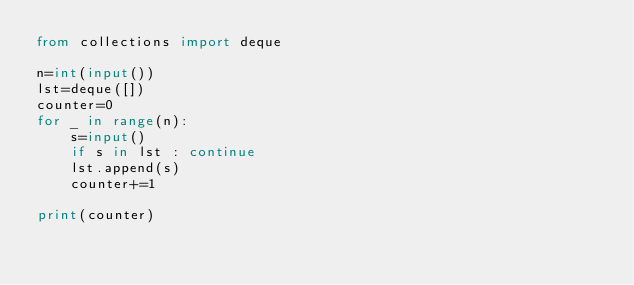<code> <loc_0><loc_0><loc_500><loc_500><_Python_>from collections import deque

n=int(input())
lst=deque([])
counter=0
for _ in range(n):
    s=input()
    if s in lst : continue
    lst.append(s)
    counter+=1

print(counter)</code> 